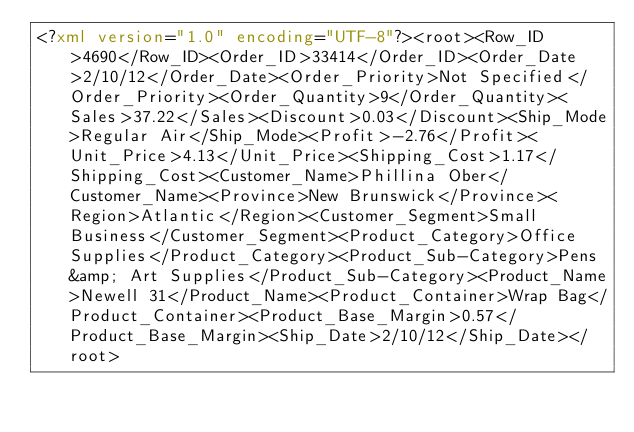<code> <loc_0><loc_0><loc_500><loc_500><_XML_><?xml version="1.0" encoding="UTF-8"?><root><Row_ID>4690</Row_ID><Order_ID>33414</Order_ID><Order_Date>2/10/12</Order_Date><Order_Priority>Not Specified</Order_Priority><Order_Quantity>9</Order_Quantity><Sales>37.22</Sales><Discount>0.03</Discount><Ship_Mode>Regular Air</Ship_Mode><Profit>-2.76</Profit><Unit_Price>4.13</Unit_Price><Shipping_Cost>1.17</Shipping_Cost><Customer_Name>Phillina Ober</Customer_Name><Province>New Brunswick</Province><Region>Atlantic</Region><Customer_Segment>Small Business</Customer_Segment><Product_Category>Office Supplies</Product_Category><Product_Sub-Category>Pens &amp; Art Supplies</Product_Sub-Category><Product_Name>Newell 31</Product_Name><Product_Container>Wrap Bag</Product_Container><Product_Base_Margin>0.57</Product_Base_Margin><Ship_Date>2/10/12</Ship_Date></root></code> 